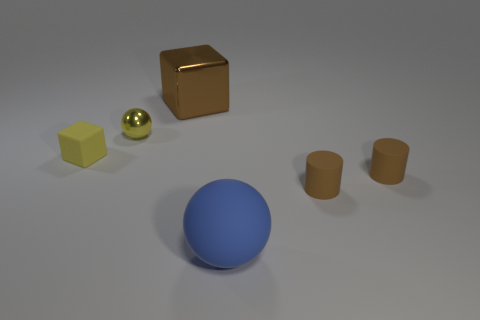The thing that is both left of the large cube and in front of the small yellow metallic ball has what shape? The object that is positioned to the left of the large cube, as well as in front of the small yellow metallic ball, exhibits a spherical shape, characterized by its smooth, round surface with a uniform blue color. 